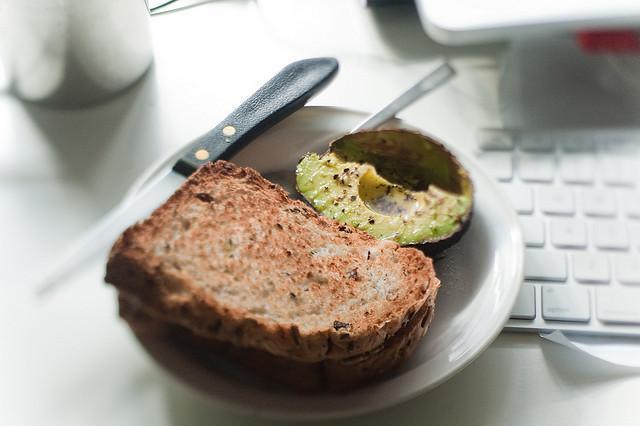What is going on the toast?
Choose the right answer from the provided options to respond to the question.
Options: Butter, cream cheese, ants, avocado. Avocado. 